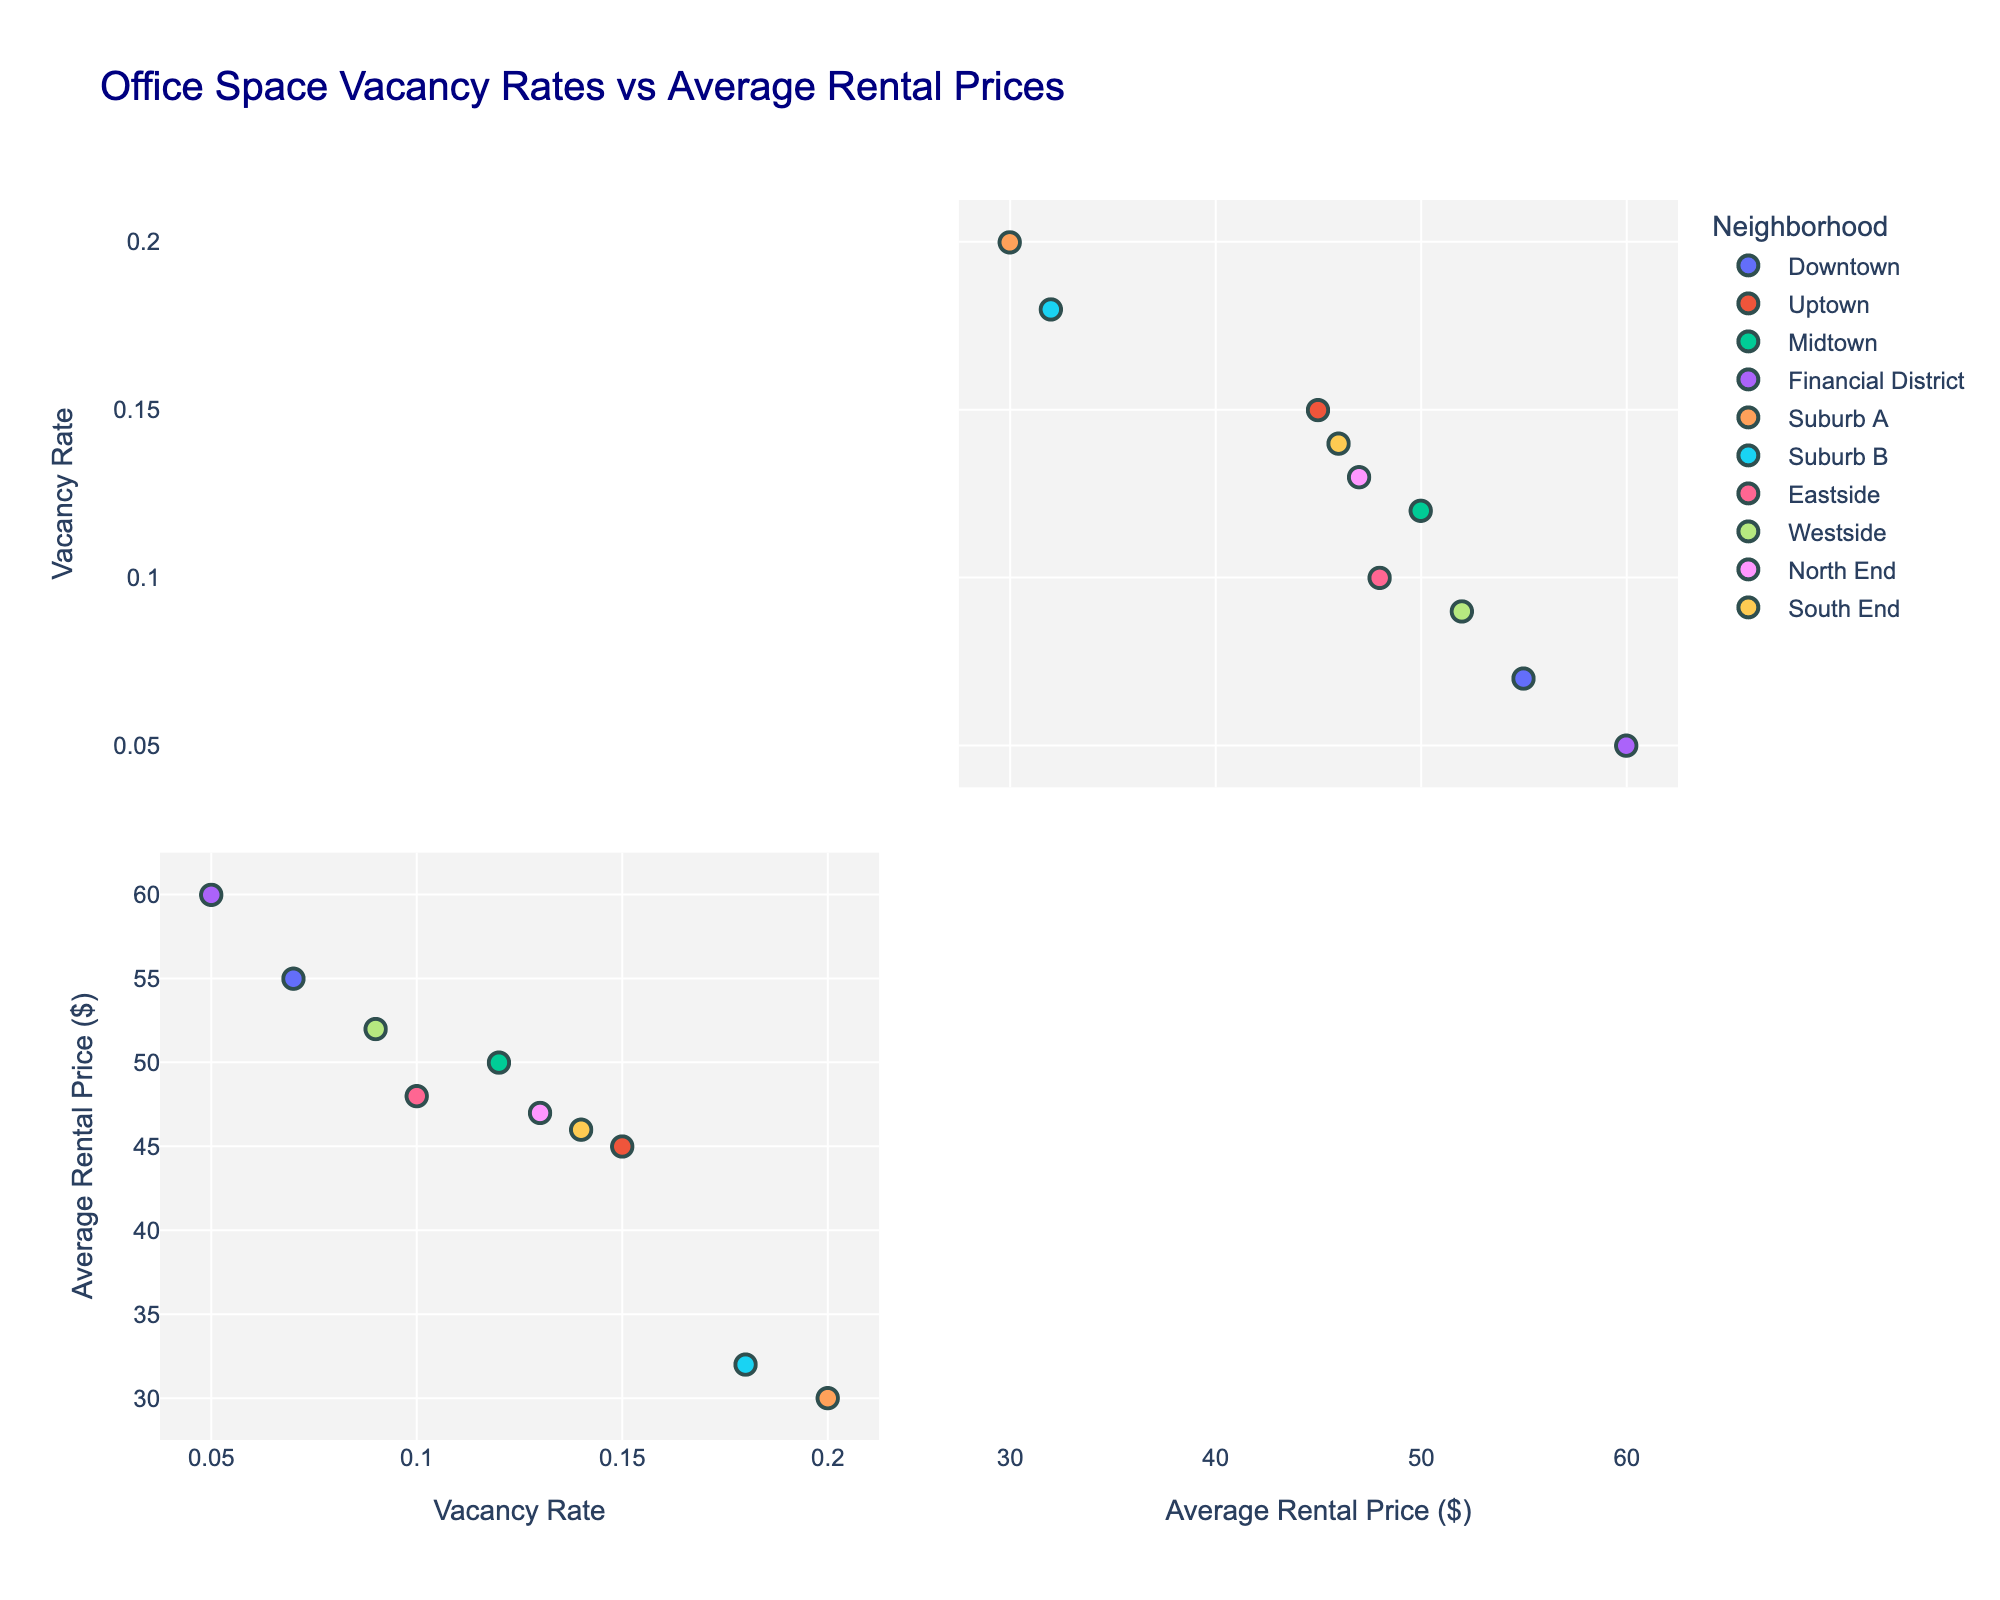How many neighborhoods are represented in the figure? By inspecting the legend, you can see that each color represents a different neighborhood. Counting these colors will give the number of neighborhoods.
Answer: 10 Which neighborhood has the lowest vacancy rate? The x-axis represents the vacancy rate. By looking for the point closest to the origin along the x-axis, you can identify that the 'Financial District' has the lowest vacancy rate.
Answer: Financial District Which neighborhood has the highest average rental price? The y-axis represents the average rental price. By locating the point highest along the y-axis, you can identify that the 'Financial District' has the highest average rental price.
Answer: Financial District Is there a neighborhood with a high vacancy rate and low average rental price? Look for a data point with a high value along the x-axis (high vacancy rate) and a low value along the y-axis (low rental price). The 'Suburb A' fits this description.
Answer: Suburb A What is the general trend between vacancy rates and average rental prices in the figure? Generally, points with higher vacancy rates (right side) have lower rental prices (bottom side). This indicates an inverse relationship between vacancy rates and rental costs.
Answer: Inverse relationship Which neighborhoods fall into both the lowest rental price category and high vacancy rate? Identify neighborhoods with low y-values and high x-values. 'Suburb A' and 'Suburb B' have lower rental prices with relatively high vacancy rates.
Answer: Suburb A, Suburb B Compare the vacancy rates of Downtown and Midtown. Locate 'Downtown' and 'Midtown' on the x-axis. Downtown has a vacancy rate closer to 0.07 while Midtown is around 0.12. Therefore, Downtown has a lower vacancy rate than Midtown.
Answer: Downtown has lower vacancy rate Are there any neighborhoods with both low vacancy rates and high average rental prices? Look for data points with low x-values and high y-values. The 'Financial District' is such a neighborhood.
Answer: Financial District Which neighborhoods have vacancy rates between 0.10 and 0.15? Find points on the x-axis whose values fall within this range. 'Midtown', 'Eastside', 'North End', and 'South End' fall within this range.
Answer: Midtown, Eastside, North End, South End What's the average rental price of the neighborhoods with vacancy rates above 0.12? First identify neighborhoods with vacancy rates above 0.12: 'Uptown', 'Suburb A', 'Suburb B', 'North End', 'South End'. Then find the average of their rental prices (45+30+32+47+46)/5 = 40.
Answer: 40 